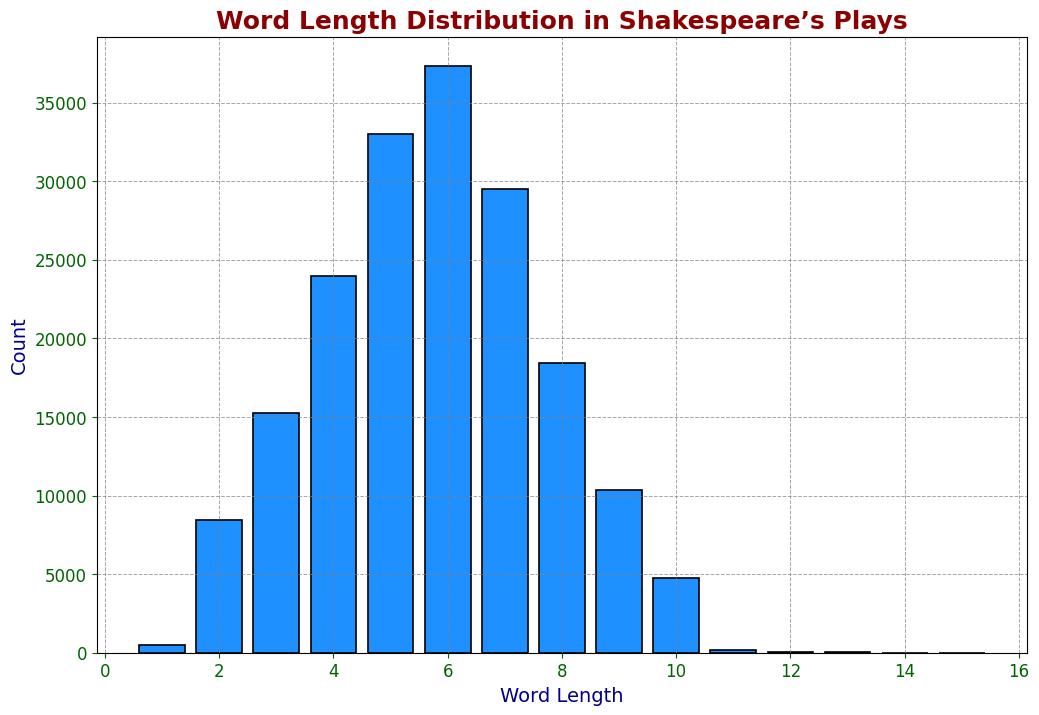Which word length occurs most frequently in Shakespeare’s plays? To determine the most frequent word length, compare the heights of the bars in the histogram. The highest bar represents the word length with the greatest count.
Answer: 6 Which word length has the least count? To find the least count, look for the shortest bar in the histogram.
Answer: 15 How many words have a length of 10 or more characters? Add the counts for word lengths of 10, 11, 12, 13, 14, and 15: 4761 + 184 + 67 + 21 + 8 + 4. The sum gives the total words with lengths 10 or more characters.
Answer: 5045 What is the difference in count between words of length 4 and length 7? Subtract the count for word length 7 from the count for word length 4: 23987 - 29512.
Answer: -5525 Are there more words with a length of 3 or with a length of 5? Compare the heights of the bars for word lengths 3 and 5. The bar for word length 5 is higher.
Answer: 5 What is the sum of the counts for word lengths 2 and 3? Add the counts for word length 2 and word length 3: 8461 + 15230.
Answer: 23691 Which word length between 5 and 8 has the greatest count? Look for the tallest bar among word lengths 5, 6, 7, and 8. The bar for word length 6 is the tallest.
Answer: 6 How many words are there with a length of 1 character? The count for word length 1 is given directly in the data.
Answer: 512 Is the count of words with a length of 9 greater than the count of words with a length of 8? Compare the heights of the bars for word lengths 8 and 9. The bar for word length 8 is taller.
Answer: No What is the average count of words for word lengths 1 to 4? Add the counts for word lengths 1, 2, 3, and 4, then divide by 4. (512 + 8461 + 15230 + 23987)/4
Answer: 12047.5 